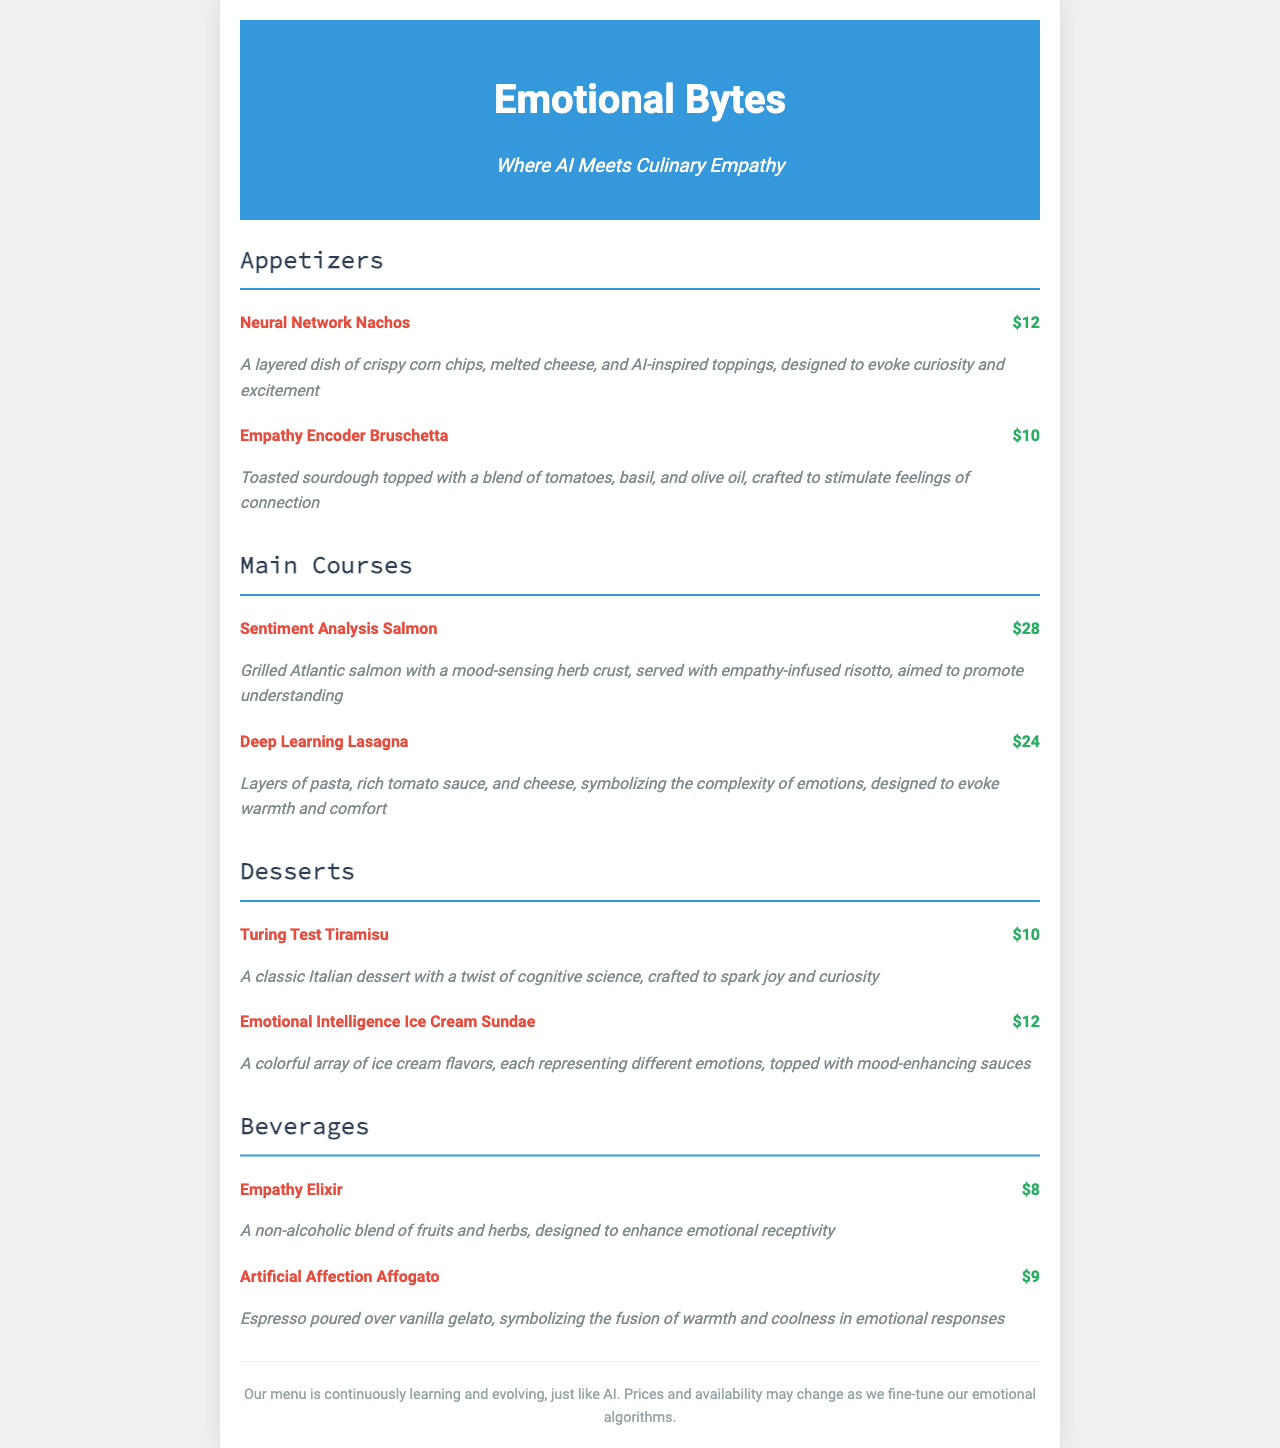What is the name of the appetizer that evokes curiosity? The question seeks the specific name of an appetizer listed in the menu that is designed to evoke curiosity, which is "Neural Network Nachos."
Answer: Neural Network Nachos How much does the Deep Learning Lasagna cost? This question asks for the price of the Deep Learning Lasagna dish, which is stated in the menu as $24.
Answer: $24 Which dessert is designed to spark joy? This question requires identifying the dessert that promotes joy from the dessert section, which is "Turing Test Tiramisu."
Answer: Turing Test Tiramisu What emotion does the Emotional Intelligence Ice Cream Sundae represent? This question looks for the general concept behind the Emotional Intelligence Ice Cream Sundae, which symbolizes different emotions.
Answer: Different emotions How many appetizers are listed on the menu? This question calculates the number of appetizers present in the menu section, which are two: Neural Network Nachos and Empathy Encoder Bruschetta.
Answer: 2 What color is used for the header background? This question examines the visual design aspect of the document by asking about the header's background color, which is blue (specifically #3498db).
Answer: Blue What type of drink is the Empathy Elixir? The question seeks to classify the Empathy Elixir based on its description in the menu, which indicates it is non-alcoholic.
Answer: Non-alcoholic Which dish is aimed to promote understanding? This questions identifies the dish that emphasizes understanding from the menu, which is "Sentiment Analysis Salmon."
Answer: Sentiment Analysis Salmon 